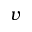<formula> <loc_0><loc_0><loc_500><loc_500>v</formula> 